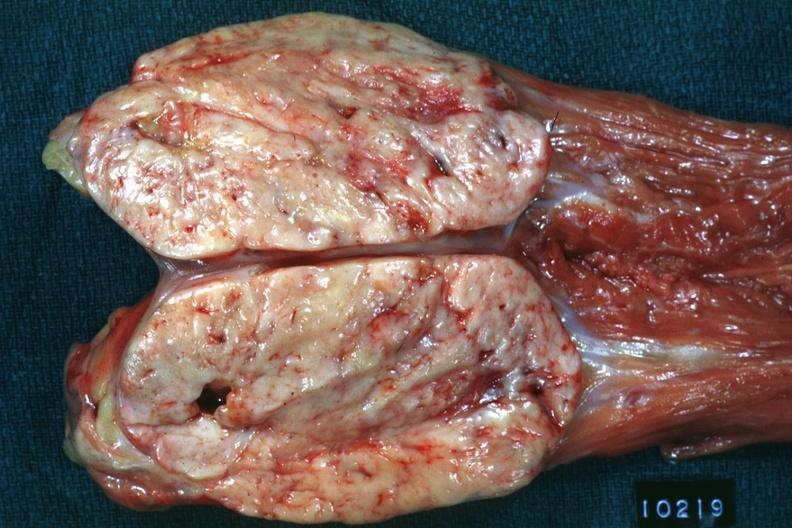s an opened peritoneal cavity cause by fibrous band strangulation present?
Answer the question using a single word or phrase. No 